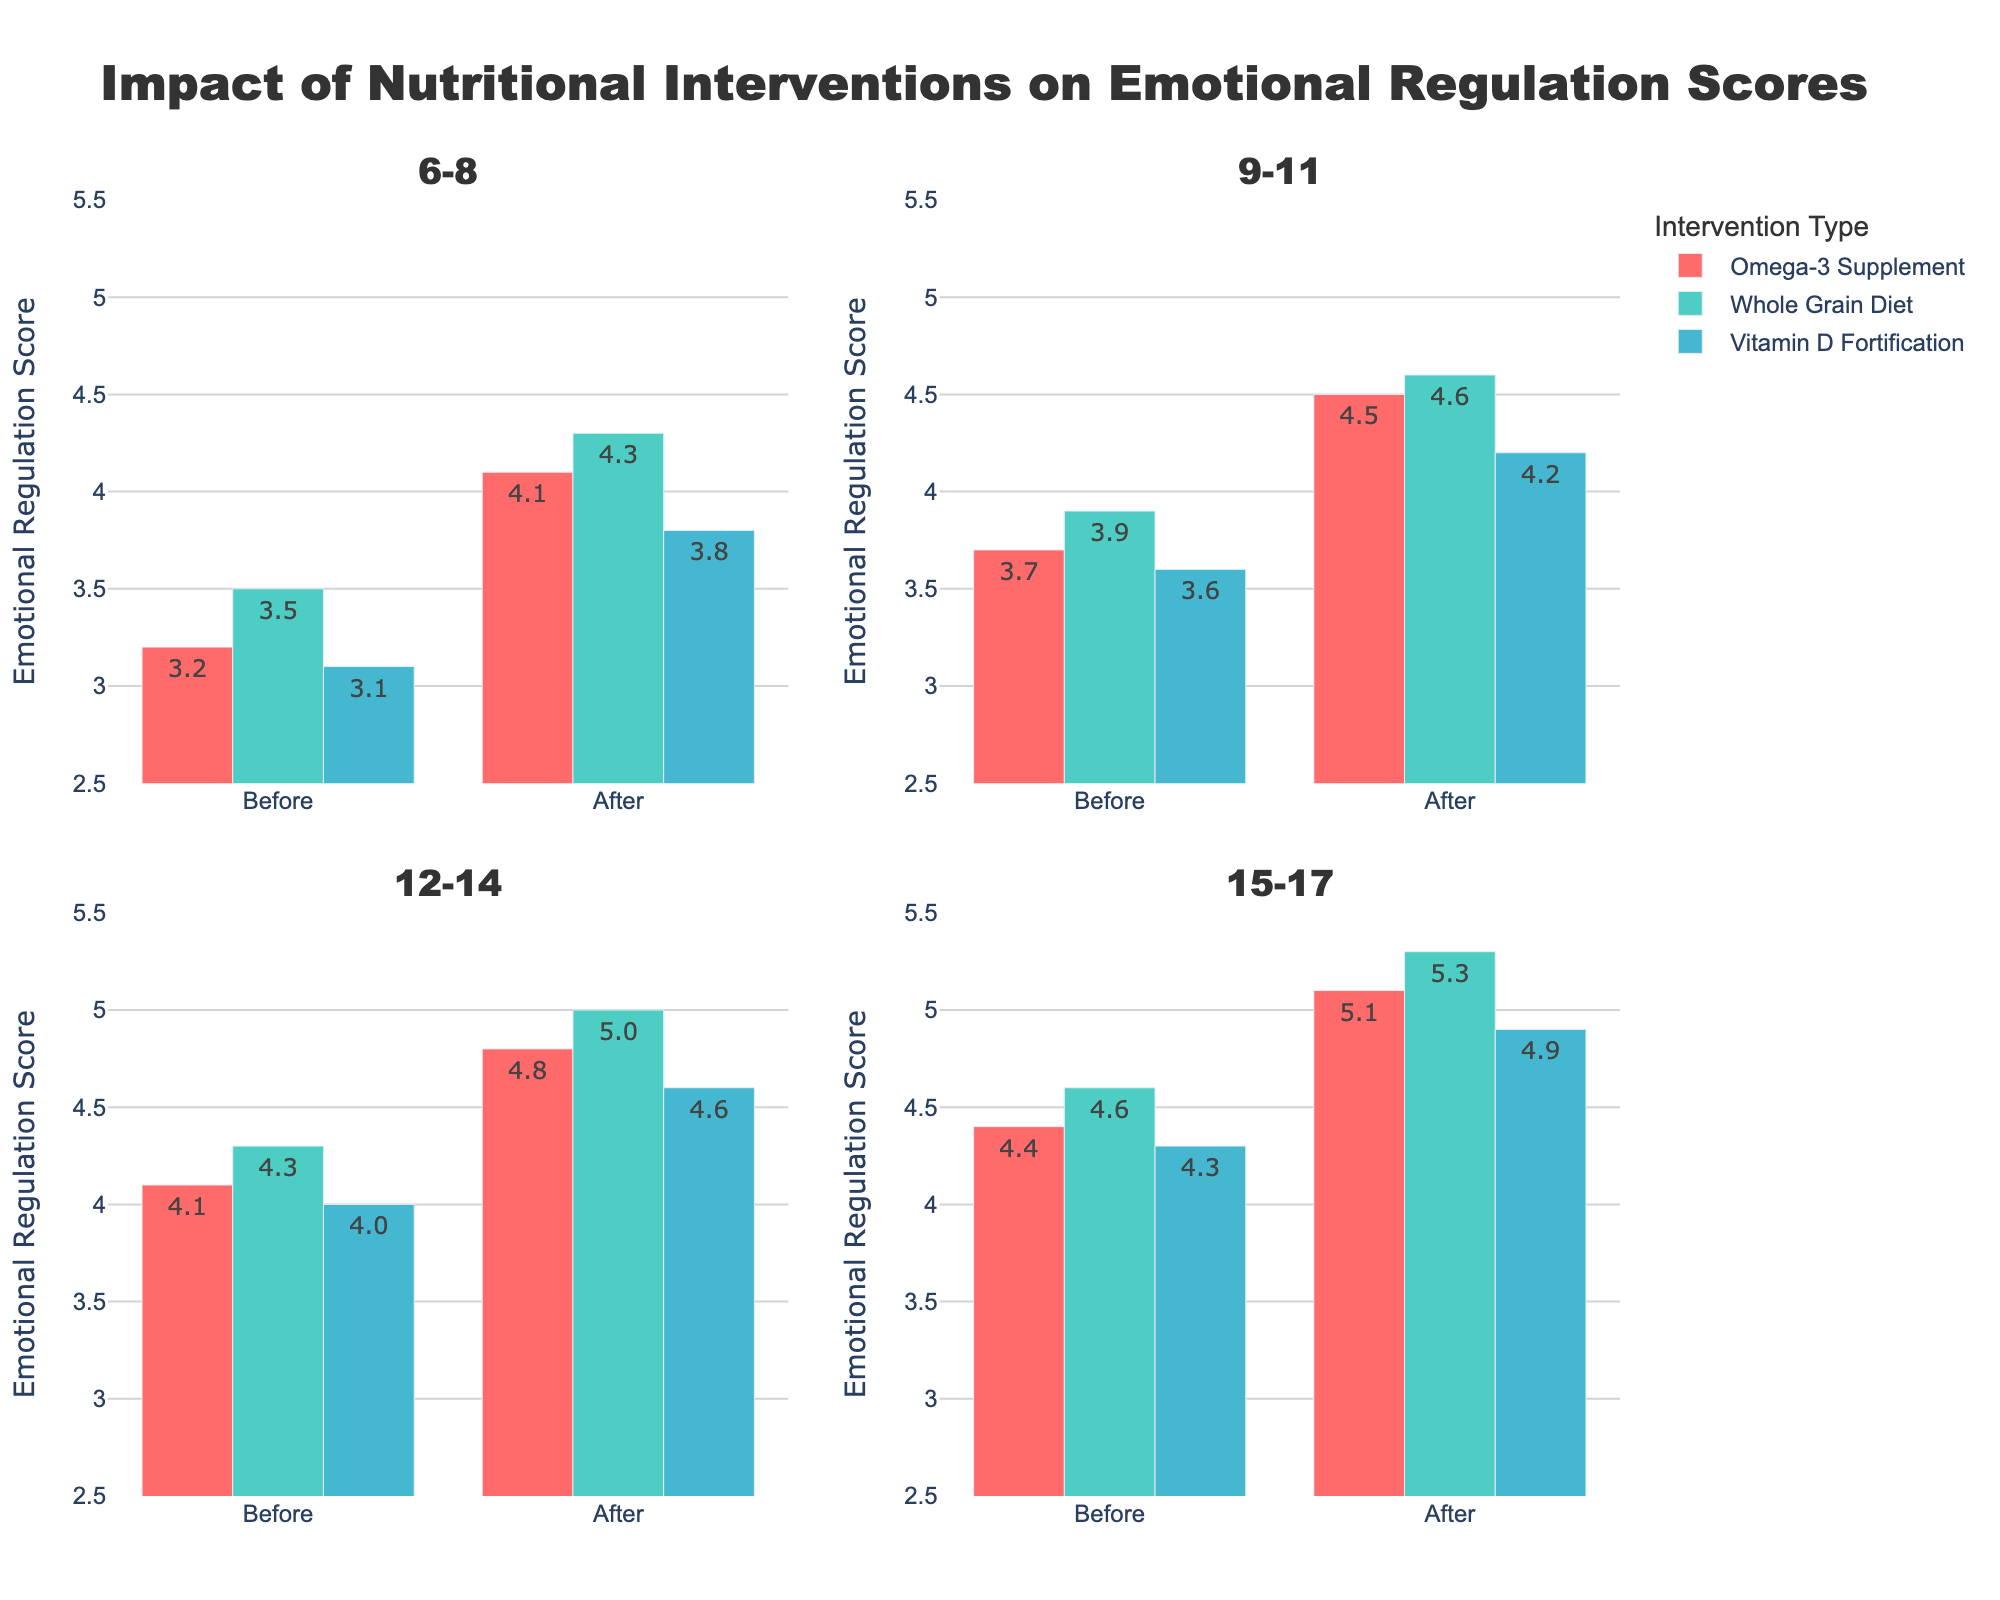What is the title of the figure? The title is located at the top of the figure and typically summarizes the content being displayed. In this case, it says, "Impact of Nutritional Interventions on Emotional Regulation Scores".
Answer: Impact of Nutritional Interventions on Emotional Regulation Scores Which intervention shows the highest improvement for the 6-8 age group? To find out which intervention shows the highest improvement, look at the difference between the Before and After scores within the 6-8 age group. The Whole Grain Diet has the highest improvement (4.3 - 3.5 = 0.8).
Answer: Whole Grain Diet What is the average score improvement for the Omega-3 Supplement across all age groups? Calculate the improvement for each age group for the Omega-3 Supplement and then average them: 
6-8: 4.1 - 3.2 = 0.9
9-11: 4.5 - 3.7 = 0.8
12-14: 4.8 - 4.1 = 0.7
15-17: 5.1 - 4.4 = 0.7
Average: (0.9 + 0.8 + 0.7 + 0.7) / 4 = 0.775
Answer: 0.775 Which age group has the lowest After Score for Vitamin D Fortification? Compare the After Scores for the Vitamin D Fortification intervention across all age groups. The 6-8 age group has the lowest After Score of 3.8.
Answer: 6-8 In the 12-14 age group, which nutritional intervention resulted in the highest After Score? By observing the bars in the 12-14 age group subplot, the Whole Grain Diet resulted in the highest After Score of 5.0.
Answer: Whole Grain Diet What is the total score improvement for all interventions in the 9-11 age group? Calculate the score improvement in the 9-11 age group for each intervention and sum up the results:
Omega-3 Supplement: 4.5 - 3.7 = 0.8
Whole Grain Diet: 4.6 - 3.9 = 0.7
Vitamin D Fortification: 4.2 - 3.6 = 0.6
Total: 0.8 + 0.7 + 0.6 = 2.1
Answer: 2.1 How does the Before Score for the Whole Grain Diet in the 15-17 age group compare to the After Score in the 6-8 age group? The Before Score for the Whole Grain Diet in the 15-17 age group is 4.6. The After Score for the Whole Grain Diet in the 6-8 age group is 4.3. 4.6 > 4.3, so the Before Score in the 15-17 age group is higher.
Answer: Higher Is there any age group where the increase in emotional regulation scores was equal for all three interventions? To answer, compare the Before and After scores for each intervention within age groups. No age group shows equal increases (differences) across all three interventions.
Answer: No 